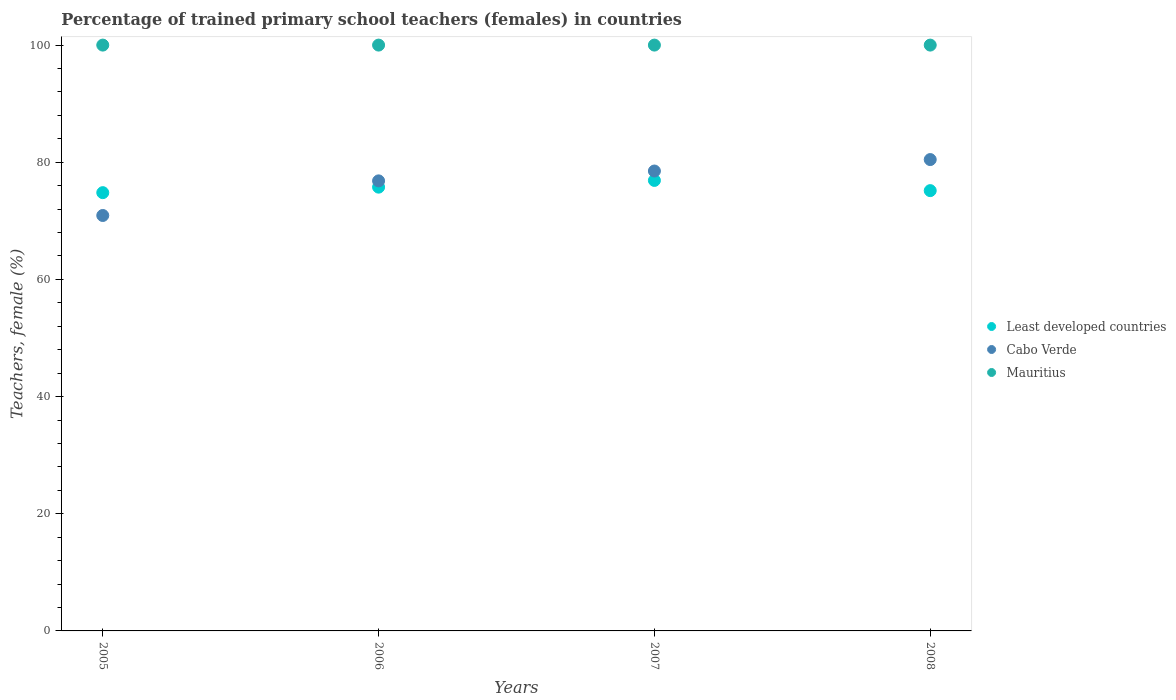Is the number of dotlines equal to the number of legend labels?
Offer a very short reply. Yes. What is the percentage of trained primary school teachers (females) in Least developed countries in 2005?
Make the answer very short. 74.81. Across all years, what is the maximum percentage of trained primary school teachers (females) in Cabo Verde?
Give a very brief answer. 80.46. Across all years, what is the minimum percentage of trained primary school teachers (females) in Least developed countries?
Your answer should be compact. 74.81. In which year was the percentage of trained primary school teachers (females) in Mauritius maximum?
Offer a very short reply. 2005. What is the difference between the percentage of trained primary school teachers (females) in Cabo Verde in 2005 and that in 2006?
Make the answer very short. -5.91. What is the difference between the percentage of trained primary school teachers (females) in Cabo Verde in 2005 and the percentage of trained primary school teachers (females) in Least developed countries in 2008?
Make the answer very short. -4.24. In the year 2008, what is the difference between the percentage of trained primary school teachers (females) in Cabo Verde and percentage of trained primary school teachers (females) in Mauritius?
Your answer should be compact. -19.54. In how many years, is the percentage of trained primary school teachers (females) in Least developed countries greater than 12 %?
Make the answer very short. 4. Is the percentage of trained primary school teachers (females) in Mauritius in 2005 less than that in 2006?
Your answer should be compact. No. What is the difference between the highest and the lowest percentage of trained primary school teachers (females) in Cabo Verde?
Your answer should be very brief. 9.55. Is the sum of the percentage of trained primary school teachers (females) in Cabo Verde in 2005 and 2008 greater than the maximum percentage of trained primary school teachers (females) in Least developed countries across all years?
Offer a terse response. Yes. Does the percentage of trained primary school teachers (females) in Mauritius monotonically increase over the years?
Keep it short and to the point. No. Is the percentage of trained primary school teachers (females) in Least developed countries strictly greater than the percentage of trained primary school teachers (females) in Cabo Verde over the years?
Keep it short and to the point. No. Is the percentage of trained primary school teachers (females) in Least developed countries strictly less than the percentage of trained primary school teachers (females) in Cabo Verde over the years?
Offer a very short reply. No. How many dotlines are there?
Provide a succinct answer. 3. What is the difference between two consecutive major ticks on the Y-axis?
Make the answer very short. 20. What is the title of the graph?
Provide a short and direct response. Percentage of trained primary school teachers (females) in countries. What is the label or title of the X-axis?
Keep it short and to the point. Years. What is the label or title of the Y-axis?
Provide a short and direct response. Teachers, female (%). What is the Teachers, female (%) of Least developed countries in 2005?
Ensure brevity in your answer.  74.81. What is the Teachers, female (%) of Cabo Verde in 2005?
Your answer should be compact. 70.91. What is the Teachers, female (%) of Least developed countries in 2006?
Your answer should be very brief. 75.75. What is the Teachers, female (%) of Cabo Verde in 2006?
Keep it short and to the point. 76.82. What is the Teachers, female (%) of Least developed countries in 2007?
Ensure brevity in your answer.  76.9. What is the Teachers, female (%) of Cabo Verde in 2007?
Provide a succinct answer. 78.5. What is the Teachers, female (%) of Mauritius in 2007?
Keep it short and to the point. 100. What is the Teachers, female (%) in Least developed countries in 2008?
Keep it short and to the point. 75.16. What is the Teachers, female (%) of Cabo Verde in 2008?
Your answer should be compact. 80.46. Across all years, what is the maximum Teachers, female (%) of Least developed countries?
Make the answer very short. 76.9. Across all years, what is the maximum Teachers, female (%) in Cabo Verde?
Your response must be concise. 80.46. Across all years, what is the maximum Teachers, female (%) of Mauritius?
Offer a terse response. 100. Across all years, what is the minimum Teachers, female (%) in Least developed countries?
Make the answer very short. 74.81. Across all years, what is the minimum Teachers, female (%) in Cabo Verde?
Ensure brevity in your answer.  70.91. What is the total Teachers, female (%) in Least developed countries in the graph?
Keep it short and to the point. 302.62. What is the total Teachers, female (%) of Cabo Verde in the graph?
Make the answer very short. 306.7. What is the difference between the Teachers, female (%) of Least developed countries in 2005 and that in 2006?
Give a very brief answer. -0.94. What is the difference between the Teachers, female (%) of Cabo Verde in 2005 and that in 2006?
Ensure brevity in your answer.  -5.91. What is the difference between the Teachers, female (%) in Mauritius in 2005 and that in 2006?
Provide a short and direct response. 0. What is the difference between the Teachers, female (%) in Least developed countries in 2005 and that in 2007?
Your answer should be very brief. -2.09. What is the difference between the Teachers, female (%) of Cabo Verde in 2005 and that in 2007?
Provide a succinct answer. -7.59. What is the difference between the Teachers, female (%) of Least developed countries in 2005 and that in 2008?
Your answer should be compact. -0.35. What is the difference between the Teachers, female (%) of Cabo Verde in 2005 and that in 2008?
Provide a succinct answer. -9.55. What is the difference between the Teachers, female (%) of Mauritius in 2005 and that in 2008?
Your answer should be very brief. 0. What is the difference between the Teachers, female (%) of Least developed countries in 2006 and that in 2007?
Ensure brevity in your answer.  -1.15. What is the difference between the Teachers, female (%) of Cabo Verde in 2006 and that in 2007?
Provide a short and direct response. -1.68. What is the difference between the Teachers, female (%) of Mauritius in 2006 and that in 2007?
Ensure brevity in your answer.  0. What is the difference between the Teachers, female (%) in Least developed countries in 2006 and that in 2008?
Make the answer very short. 0.59. What is the difference between the Teachers, female (%) in Cabo Verde in 2006 and that in 2008?
Offer a very short reply. -3.64. What is the difference between the Teachers, female (%) of Least developed countries in 2007 and that in 2008?
Your answer should be compact. 1.74. What is the difference between the Teachers, female (%) in Cabo Verde in 2007 and that in 2008?
Offer a terse response. -1.96. What is the difference between the Teachers, female (%) of Least developed countries in 2005 and the Teachers, female (%) of Cabo Verde in 2006?
Ensure brevity in your answer.  -2.01. What is the difference between the Teachers, female (%) of Least developed countries in 2005 and the Teachers, female (%) of Mauritius in 2006?
Your answer should be compact. -25.19. What is the difference between the Teachers, female (%) in Cabo Verde in 2005 and the Teachers, female (%) in Mauritius in 2006?
Provide a short and direct response. -29.09. What is the difference between the Teachers, female (%) of Least developed countries in 2005 and the Teachers, female (%) of Cabo Verde in 2007?
Provide a short and direct response. -3.69. What is the difference between the Teachers, female (%) of Least developed countries in 2005 and the Teachers, female (%) of Mauritius in 2007?
Provide a succinct answer. -25.19. What is the difference between the Teachers, female (%) in Cabo Verde in 2005 and the Teachers, female (%) in Mauritius in 2007?
Give a very brief answer. -29.09. What is the difference between the Teachers, female (%) of Least developed countries in 2005 and the Teachers, female (%) of Cabo Verde in 2008?
Provide a succinct answer. -5.65. What is the difference between the Teachers, female (%) of Least developed countries in 2005 and the Teachers, female (%) of Mauritius in 2008?
Keep it short and to the point. -25.19. What is the difference between the Teachers, female (%) of Cabo Verde in 2005 and the Teachers, female (%) of Mauritius in 2008?
Keep it short and to the point. -29.09. What is the difference between the Teachers, female (%) of Least developed countries in 2006 and the Teachers, female (%) of Cabo Verde in 2007?
Your answer should be compact. -2.75. What is the difference between the Teachers, female (%) of Least developed countries in 2006 and the Teachers, female (%) of Mauritius in 2007?
Provide a succinct answer. -24.25. What is the difference between the Teachers, female (%) of Cabo Verde in 2006 and the Teachers, female (%) of Mauritius in 2007?
Your answer should be very brief. -23.18. What is the difference between the Teachers, female (%) of Least developed countries in 2006 and the Teachers, female (%) of Cabo Verde in 2008?
Provide a short and direct response. -4.71. What is the difference between the Teachers, female (%) of Least developed countries in 2006 and the Teachers, female (%) of Mauritius in 2008?
Your answer should be compact. -24.25. What is the difference between the Teachers, female (%) in Cabo Verde in 2006 and the Teachers, female (%) in Mauritius in 2008?
Your answer should be very brief. -23.18. What is the difference between the Teachers, female (%) in Least developed countries in 2007 and the Teachers, female (%) in Cabo Verde in 2008?
Make the answer very short. -3.56. What is the difference between the Teachers, female (%) of Least developed countries in 2007 and the Teachers, female (%) of Mauritius in 2008?
Give a very brief answer. -23.1. What is the difference between the Teachers, female (%) of Cabo Verde in 2007 and the Teachers, female (%) of Mauritius in 2008?
Your response must be concise. -21.5. What is the average Teachers, female (%) of Least developed countries per year?
Provide a short and direct response. 75.65. What is the average Teachers, female (%) in Cabo Verde per year?
Give a very brief answer. 76.68. What is the average Teachers, female (%) in Mauritius per year?
Provide a succinct answer. 100. In the year 2005, what is the difference between the Teachers, female (%) of Least developed countries and Teachers, female (%) of Cabo Verde?
Give a very brief answer. 3.9. In the year 2005, what is the difference between the Teachers, female (%) in Least developed countries and Teachers, female (%) in Mauritius?
Offer a very short reply. -25.19. In the year 2005, what is the difference between the Teachers, female (%) of Cabo Verde and Teachers, female (%) of Mauritius?
Your answer should be very brief. -29.09. In the year 2006, what is the difference between the Teachers, female (%) in Least developed countries and Teachers, female (%) in Cabo Verde?
Offer a very short reply. -1.07. In the year 2006, what is the difference between the Teachers, female (%) in Least developed countries and Teachers, female (%) in Mauritius?
Your answer should be very brief. -24.25. In the year 2006, what is the difference between the Teachers, female (%) in Cabo Verde and Teachers, female (%) in Mauritius?
Your answer should be compact. -23.18. In the year 2007, what is the difference between the Teachers, female (%) of Least developed countries and Teachers, female (%) of Cabo Verde?
Keep it short and to the point. -1.6. In the year 2007, what is the difference between the Teachers, female (%) in Least developed countries and Teachers, female (%) in Mauritius?
Provide a short and direct response. -23.1. In the year 2007, what is the difference between the Teachers, female (%) of Cabo Verde and Teachers, female (%) of Mauritius?
Keep it short and to the point. -21.5. In the year 2008, what is the difference between the Teachers, female (%) in Least developed countries and Teachers, female (%) in Cabo Verde?
Provide a succinct answer. -5.3. In the year 2008, what is the difference between the Teachers, female (%) of Least developed countries and Teachers, female (%) of Mauritius?
Make the answer very short. -24.84. In the year 2008, what is the difference between the Teachers, female (%) of Cabo Verde and Teachers, female (%) of Mauritius?
Ensure brevity in your answer.  -19.54. What is the ratio of the Teachers, female (%) of Least developed countries in 2005 to that in 2006?
Make the answer very short. 0.99. What is the ratio of the Teachers, female (%) of Cabo Verde in 2005 to that in 2006?
Offer a terse response. 0.92. What is the ratio of the Teachers, female (%) in Least developed countries in 2005 to that in 2007?
Your answer should be compact. 0.97. What is the ratio of the Teachers, female (%) of Cabo Verde in 2005 to that in 2007?
Provide a short and direct response. 0.9. What is the ratio of the Teachers, female (%) in Mauritius in 2005 to that in 2007?
Your answer should be very brief. 1. What is the ratio of the Teachers, female (%) in Least developed countries in 2005 to that in 2008?
Keep it short and to the point. 1. What is the ratio of the Teachers, female (%) of Cabo Verde in 2005 to that in 2008?
Make the answer very short. 0.88. What is the ratio of the Teachers, female (%) in Least developed countries in 2006 to that in 2007?
Keep it short and to the point. 0.99. What is the ratio of the Teachers, female (%) of Cabo Verde in 2006 to that in 2007?
Your answer should be compact. 0.98. What is the ratio of the Teachers, female (%) of Mauritius in 2006 to that in 2007?
Make the answer very short. 1. What is the ratio of the Teachers, female (%) of Least developed countries in 2006 to that in 2008?
Provide a short and direct response. 1.01. What is the ratio of the Teachers, female (%) of Cabo Verde in 2006 to that in 2008?
Provide a succinct answer. 0.95. What is the ratio of the Teachers, female (%) of Least developed countries in 2007 to that in 2008?
Your answer should be very brief. 1.02. What is the ratio of the Teachers, female (%) of Cabo Verde in 2007 to that in 2008?
Offer a terse response. 0.98. What is the difference between the highest and the second highest Teachers, female (%) of Least developed countries?
Your answer should be compact. 1.15. What is the difference between the highest and the second highest Teachers, female (%) in Cabo Verde?
Keep it short and to the point. 1.96. What is the difference between the highest and the second highest Teachers, female (%) in Mauritius?
Provide a succinct answer. 0. What is the difference between the highest and the lowest Teachers, female (%) of Least developed countries?
Keep it short and to the point. 2.09. What is the difference between the highest and the lowest Teachers, female (%) of Cabo Verde?
Offer a terse response. 9.55. 